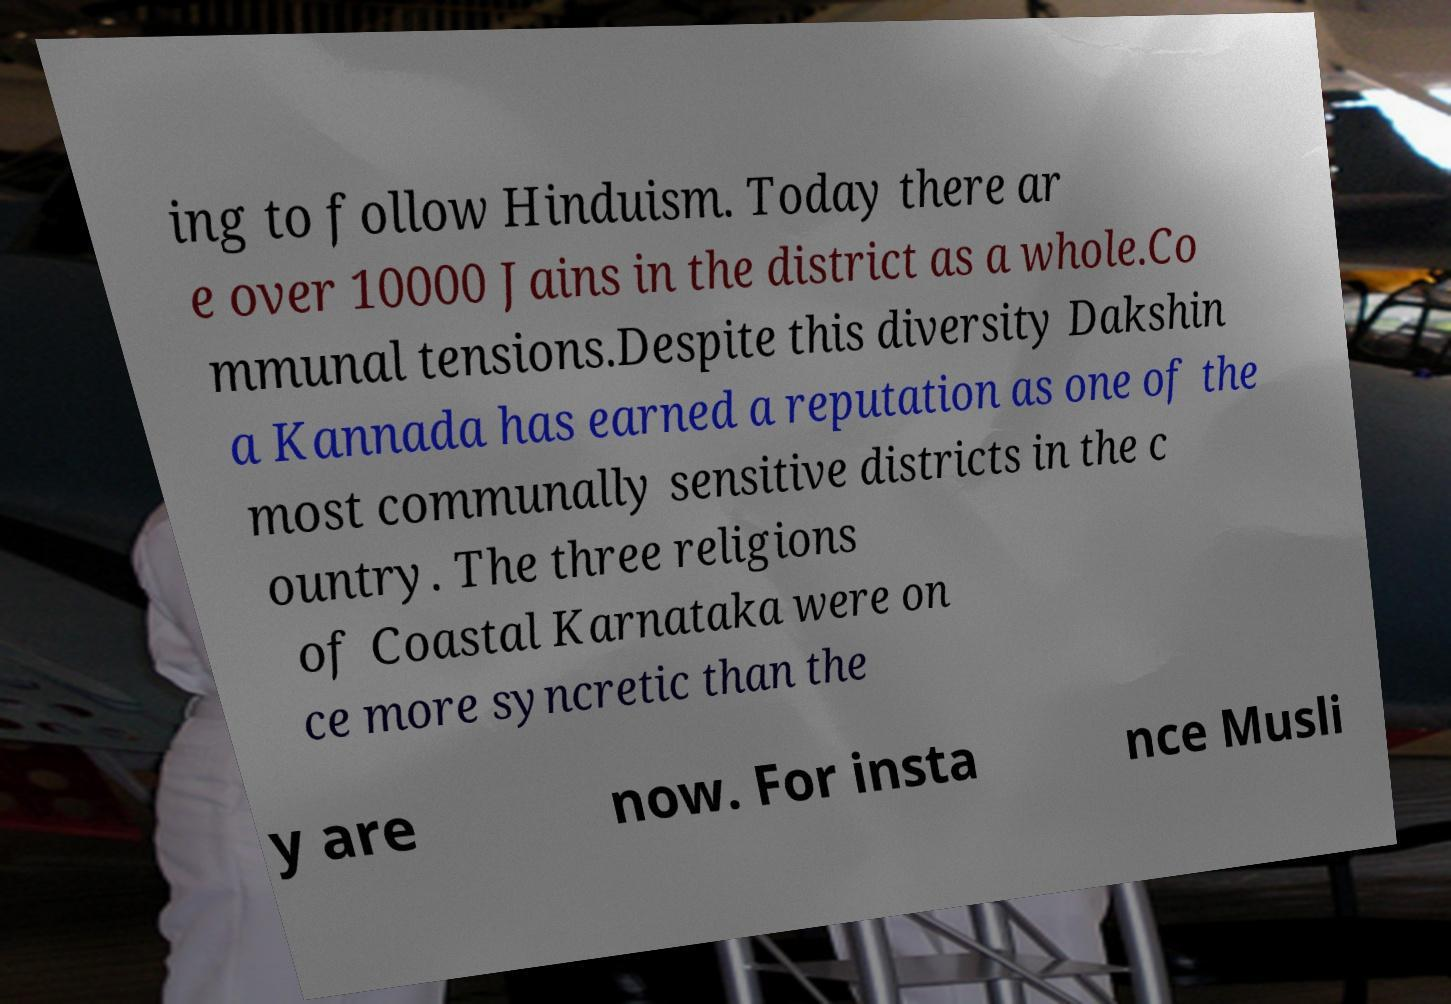Could you extract and type out the text from this image? ing to follow Hinduism. Today there ar e over 10000 Jains in the district as a whole.Co mmunal tensions.Despite this diversity Dakshin a Kannada has earned a reputation as one of the most communally sensitive districts in the c ountry. The three religions of Coastal Karnataka were on ce more syncretic than the y are now. For insta nce Musli 